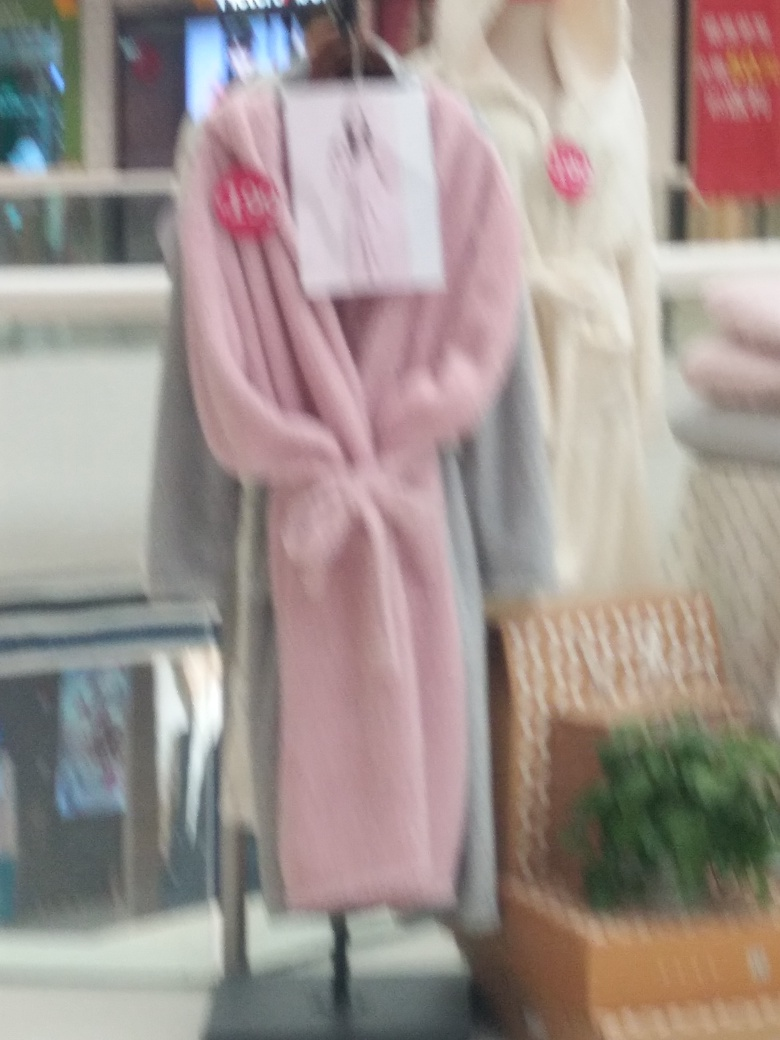Do you see any indications of the photo being taken in a hurry? Based on the blurriness and lack of focus in the image, it does give the impression that the photo may have been taken quickly or without steady handling of the camera. 